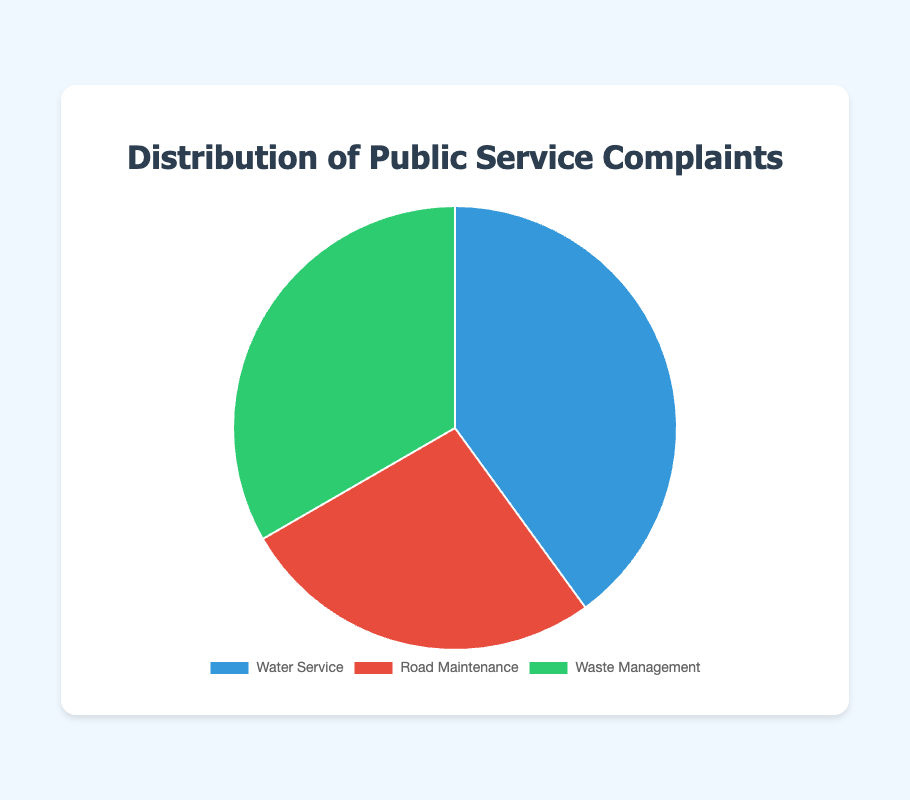Which category has the highest number of complaints? The category with the highest number of complaints is determined by comparing the data points in the pie chart. Water Service has 120 complaints, Waste Management has 100 complaints, and Road Maintenance has 80 complaints. Therefore, Water Service has the highest number of complaints.
Answer: Water Service How many more complaints does Water Service have compared to Road Maintenance? To find out how many more complaints Water Service has compared to Road Maintenance, we subtract the number of complaints for Road Maintenance from the number of complaints for Water Service: 120 - 80 = 40.
Answer: 40 Which color represents Waste Management in the pie chart? By looking at the legend associated with the pie chart, we can see that Waste Management is represented by the green segment.
Answer: Green What is the total number of public service complaints? To calculate the total number of public service complaints, we sum the complaints from all categories: 120 (Water Service) + 80 (Road Maintenance) + 100 (Waste Management) = 300.
Answer: 300 What percentage of the total complaints are for Road Maintenance? To find the percentage of the total complaints that are for Road Maintenance, we divide the number of Road Maintenance complaints by the total number of complaints and multiply by 100: (80 / 300) * 100 ≈ 26.67%.
Answer: 26.67% Which category has fewer complaints, Waste Management or Road Maintenance? To find which category has fewer complaints, we compare the numbers: Waste Management has 100 complaints and Road Maintenance has 80 complaints. Road Maintenance has fewer complaints.
Answer: Road Maintenance How many complaints are there in categories excluding Water Service? To find the complaints excluding Water Service, we sum the complaints for Road Maintenance and Waste Management: 80 (Road Maintenance) + 100 (Waste Management) = 180.
Answer: 180 What is the difference in the number of complaints between the category with the most complaints and the category with the least complaints? The category with the most complaints is Water Service with 120 complaints, and the category with the least complaints is Road Maintenance with 80 complaints. The difference is calculated as 120 - 80 = 40.
Answer: 40 If the total number of complaints increased by 50, how many total complaints would there be? Adding 50 to the current total number of complaints (300): 300 + 50 = 350.
Answer: 350 What fraction of the total complaints is represented by Waste Management? To calculate the fraction of the total complaints represented by Waste Management, divide the number of Waste Management complaints by the total number of complaints: 100 / 300 = 1/3.
Answer: 1/3 